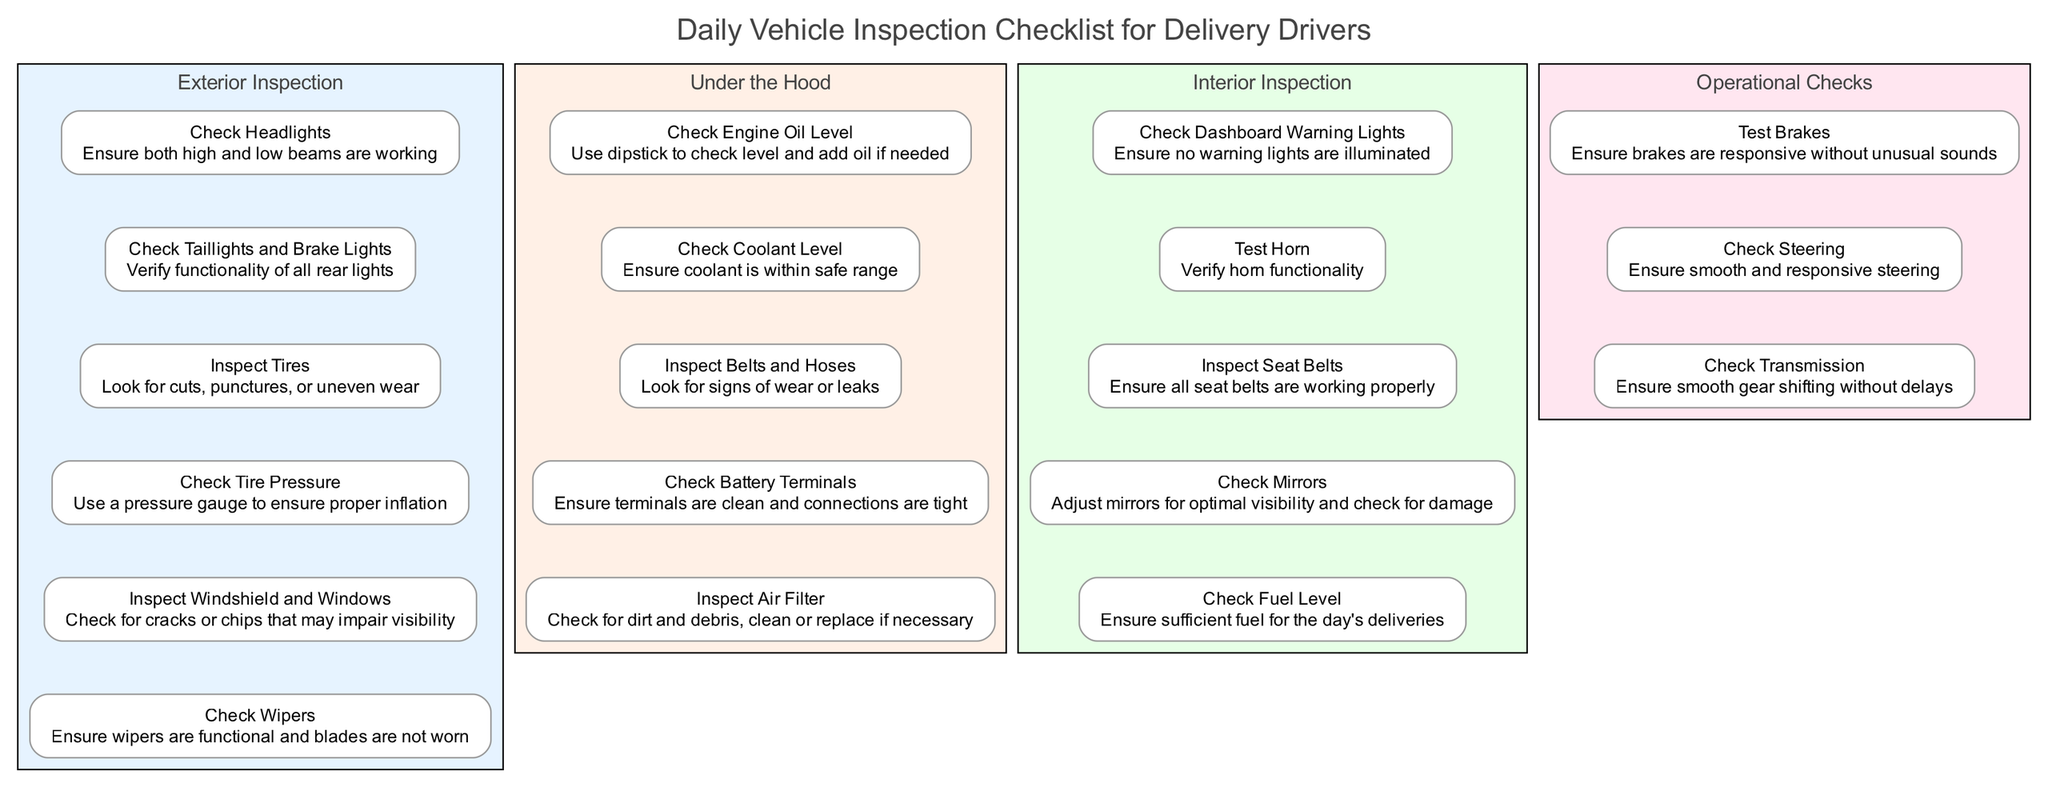What are the two main categories in the checklist? The diagram features four blocks which can be summarized as: Exterior Inspection, Under the Hood, Interior Inspection, and Operational Checks. Thus, referring to the two main categories, 'Exterior Inspection' and 'Under the Hood' can easily depict the basic divisions of the scope of this checklist.
Answer: Exterior Inspection, Under the Hood How many elements are listed under 'Operational Checks'? By counting the elements within the 'Operational Checks' block, there are three distinct elements: Test Brakes, Check Steering, and Check Transmission. This makes it easy to derive the total number of elements by simply counting them.
Answer: 3 What should be checked to ensure the tires are safe? Within the 'Exterior Inspection' block, the elements specifically mentioning tires include 'Inspect Tires' and 'Check Tire Pressure.' Inspecting for cuts, punctures, and uneven wear and ensuring proper inflation fulfills the safety checks on tires.
Answer: Inspect Tires, Check Tire Pressure Which inspection involves checking the dashboard? The check related to the dashboard occurs within the 'Interior Inspection' block, specifically the element called 'Check Dashboard Warning Lights' which ensures that no warning lights are illuminated on the dashboard. This directly ties the dashboard inspection to the interior elements.
Answer: Check Dashboard Warning Lights Which block includes checking battery terminals? 'Under the Hood' features the element 'Check Battery Terminals,' which involves ensuring that terminals are clean and that the connections are tight. This relationship shows that battery checks are part of the deeper internal vehicle checks rather than the exterior or operational checks.
Answer: Under the Hood 